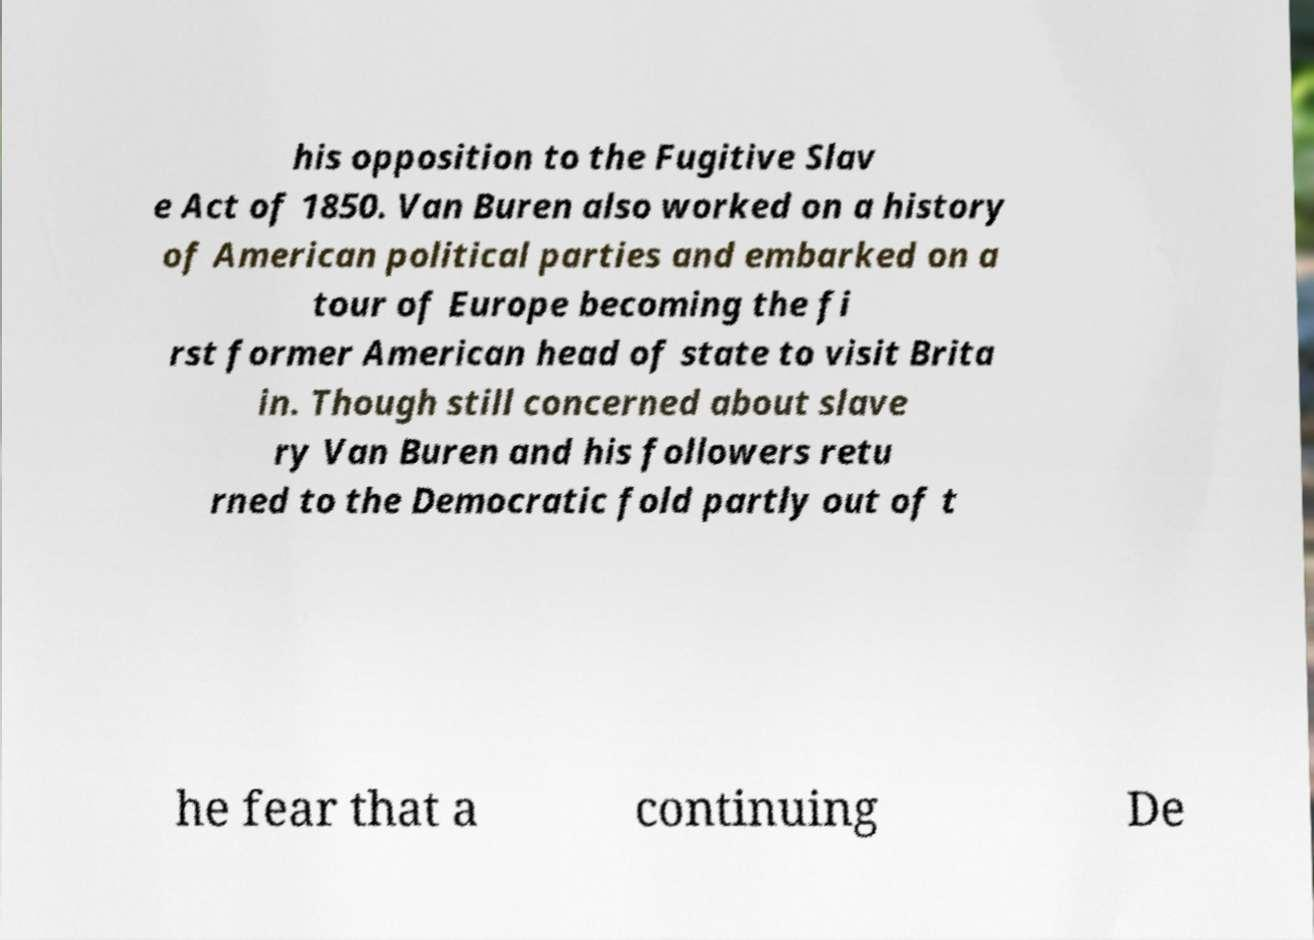Can you accurately transcribe the text from the provided image for me? his opposition to the Fugitive Slav e Act of 1850. Van Buren also worked on a history of American political parties and embarked on a tour of Europe becoming the fi rst former American head of state to visit Brita in. Though still concerned about slave ry Van Buren and his followers retu rned to the Democratic fold partly out of t he fear that a continuing De 